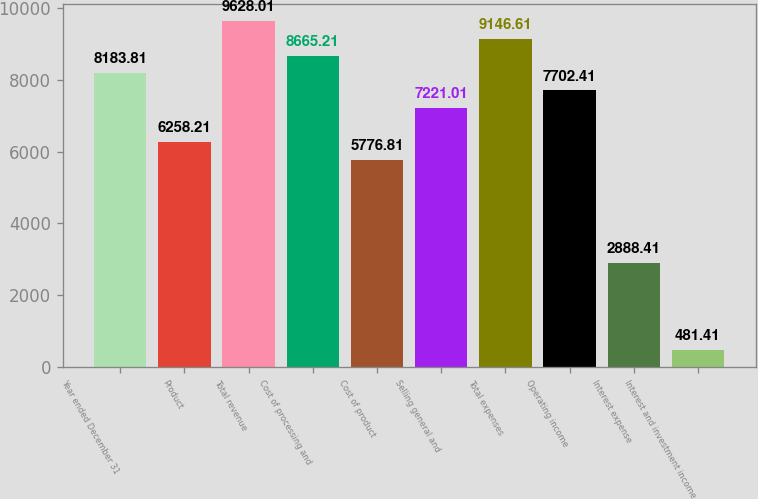<chart> <loc_0><loc_0><loc_500><loc_500><bar_chart><fcel>Year ended December 31<fcel>Product<fcel>Total revenue<fcel>Cost of processing and<fcel>Cost of product<fcel>Selling general and<fcel>Total expenses<fcel>Operating income<fcel>Interest expense<fcel>Interest and investment income<nl><fcel>8183.81<fcel>6258.21<fcel>9628.01<fcel>8665.21<fcel>5776.81<fcel>7221.01<fcel>9146.61<fcel>7702.41<fcel>2888.41<fcel>481.41<nl></chart> 